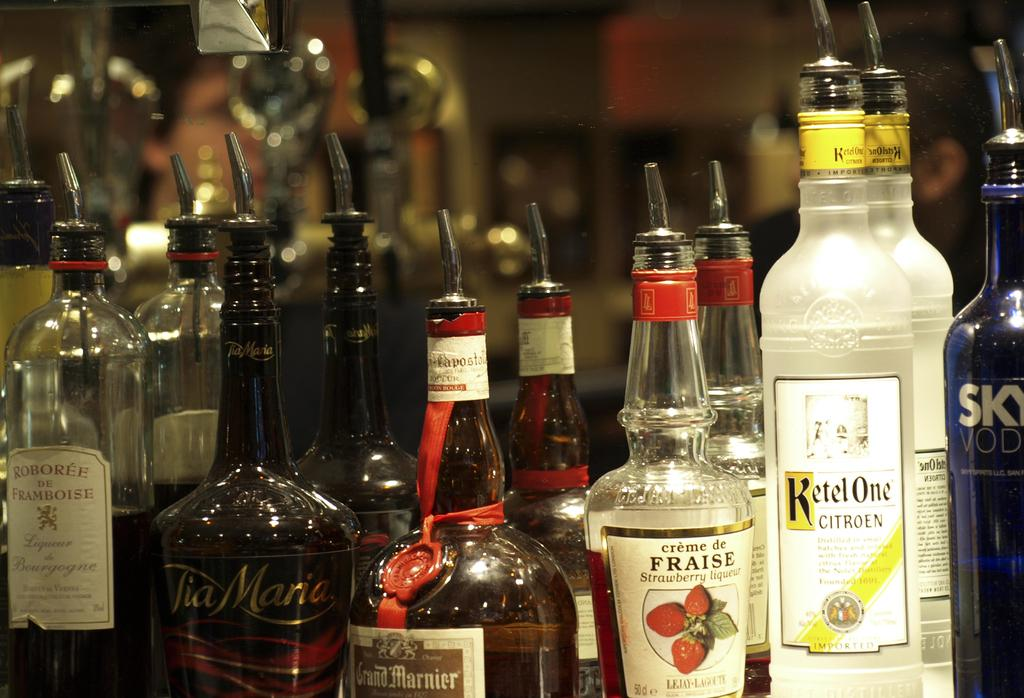Provide a one-sentence caption for the provided image. Alcohol bottles on a counter with one that says FRAISE. 